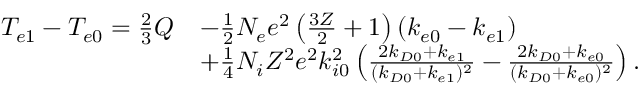<formula> <loc_0><loc_0><loc_500><loc_500>\begin{array} { r l } { T _ { e 1 } - T _ { e 0 } = \frac { 2 } { 3 } Q } & { - \frac { 1 } { 2 } N _ { e } e ^ { 2 } \left ( \frac { 3 Z } { 2 } + 1 \right ) ( k _ { e 0 } - k _ { e 1 } ) } \\ & { + \frac { 1 } { 4 } N _ { i } Z ^ { 2 } e ^ { 2 } k _ { i 0 } ^ { 2 } \left ( \frac { 2 k _ { D 0 } + k _ { e 1 } } { ( k _ { D 0 } + k _ { e 1 } ) ^ { 2 } } - \frac { 2 k _ { D 0 } + k _ { e 0 } } { ( k _ { D 0 } + k _ { e 0 } ) ^ { 2 } } \right ) . } \end{array}</formula> 